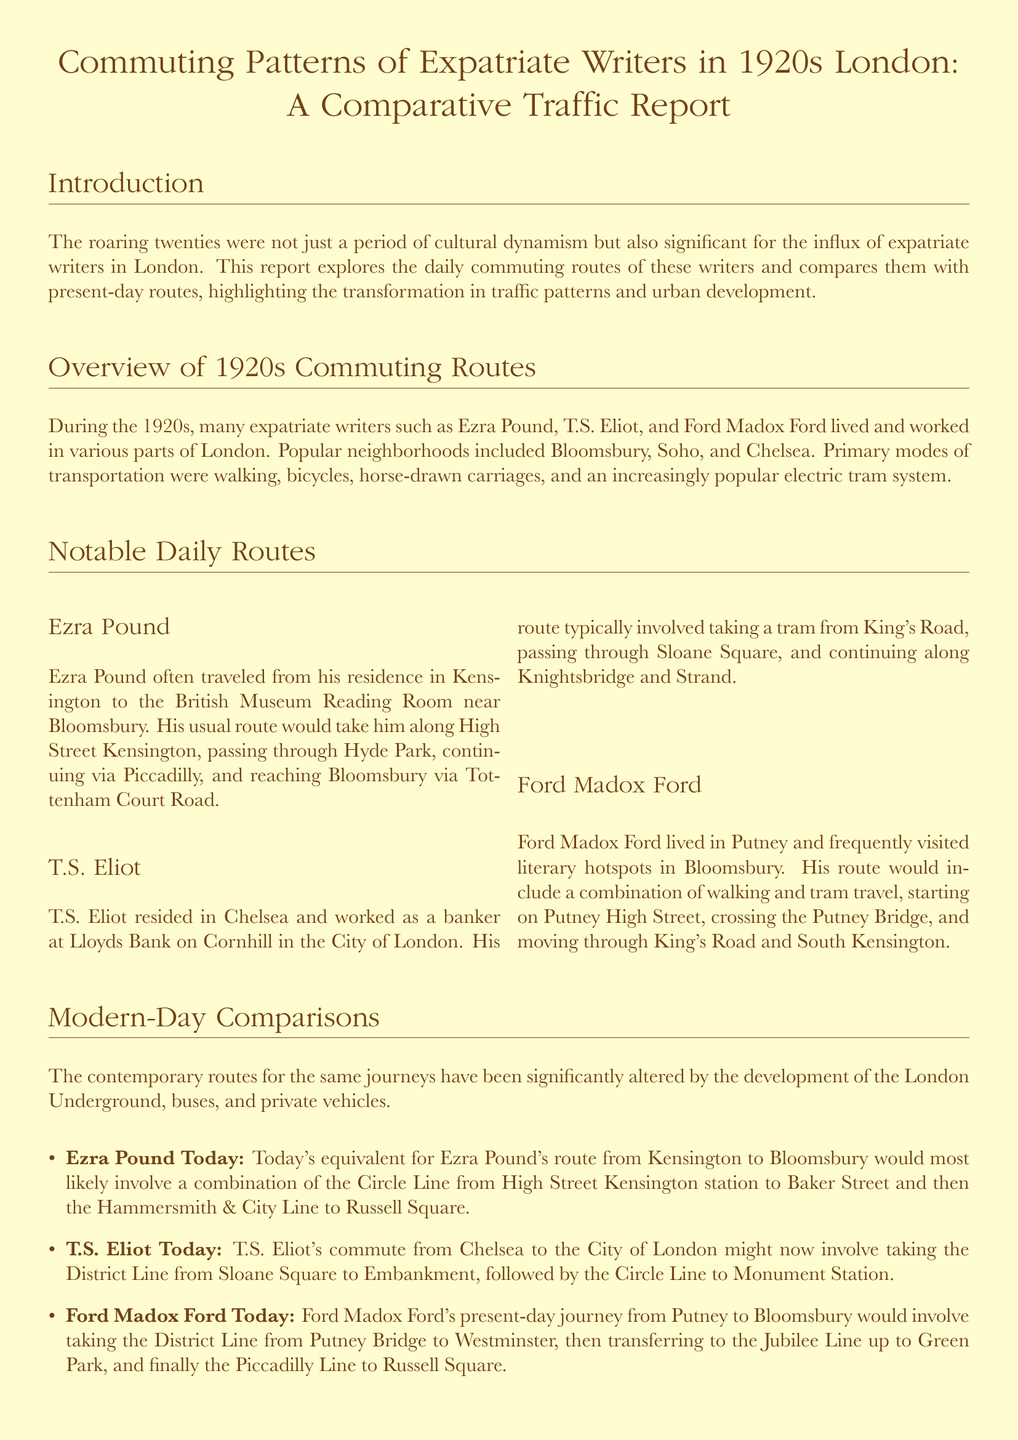What neighborhoods did expatriate writers commonly reside in during the 1920s? The document mentions Bloomsbury, Soho, and Chelsea as popular neighborhoods for expatriate writers in London during the 1920s.
Answer: Bloomsbury, Soho, Chelsea Which writer traveled from Kensington to the British Museum? The document specifies that Ezra Pound often traveled from his residence in Kensington to the British Museum Reading Room in Bloomsbury.
Answer: Ezra Pound What transportation mode was increasingly popular in the 1920s? The report states that the electric tram system became an increasingly popular mode of transportation during the 1920s.
Answer: Electric tram system What is the modern equivalent route for Ezra Pound's commute? The document outlines that today, Ezra Pound's route would likely involve a combination of the Circle Line from High Street Kensington to Baker Street and then the Hammersmith & City Line to Russell Square.
Answer: Circle Line and Hammersmith & City Line How did T.S. Eliot commute from Chelsea to the City of London today? According to the document, T.S. Eliot's modern-day commute would involve taking the District Line from Sloane Square to Embankment, followed by the Circle Line to Monument Station.
Answer: District Line and Circle Line What was the primary mode of transportation for expatriate writers in the 1920s? The report lists walking, bicycles, horse-drawn carriages, and an electric tram system as primary modes of transportation for expatriate writers in the 1920s.
Answer: Walking, bicycles, horse-drawn carriages, electric tram system What is the main theme of the conclusion? The conclusion discusses the transformation of commuting routes reflecting broader changes in urban living and the influence of transportation innovations on daily life.
Answer: Transformation of commuting routes Which writer lived in Putney? The document specifies that Ford Madox Ford lived in Putney.
Answer: Ford Madox Ford 